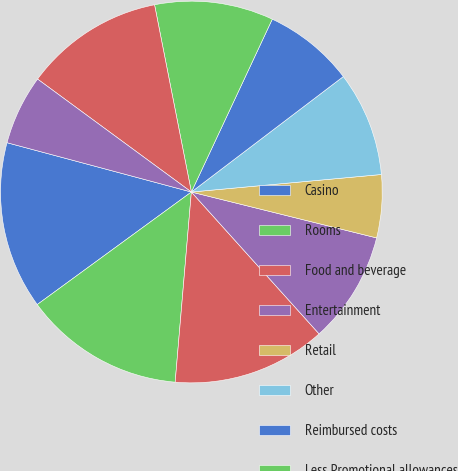Convert chart to OTSL. <chart><loc_0><loc_0><loc_500><loc_500><pie_chart><fcel>Casino<fcel>Rooms<fcel>Food and beverage<fcel>Entertainment<fcel>Retail<fcel>Other<fcel>Reimbursed costs<fcel>Less Promotional allowances<fcel>General and administrative<fcel>Corporate expense<nl><fcel>14.2%<fcel>13.61%<fcel>13.02%<fcel>9.47%<fcel>5.33%<fcel>8.88%<fcel>7.69%<fcel>10.06%<fcel>11.83%<fcel>5.92%<nl></chart> 